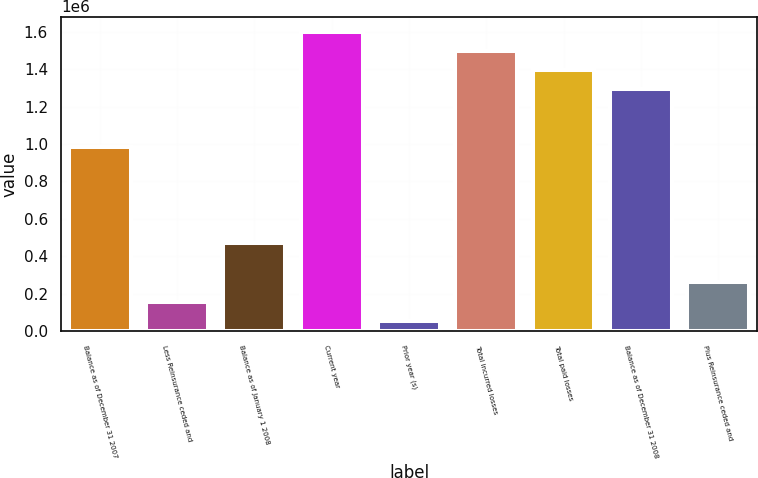<chart> <loc_0><loc_0><loc_500><loc_500><bar_chart><fcel>Balance as of December 31 2007<fcel>Less Reinsurance ceded and<fcel>Balance as of January 1 2008<fcel>Current year<fcel>Prior year (s)<fcel>Total incurred losses<fcel>Total paid losses<fcel>Balance as of December 31 2008<fcel>Plus Reinsurance ceded and<nl><fcel>984846<fcel>158074<fcel>471974<fcel>1.60029e+06<fcel>55499<fcel>1.49772e+06<fcel>1.39514e+06<fcel>1.29257e+06<fcel>260648<nl></chart> 